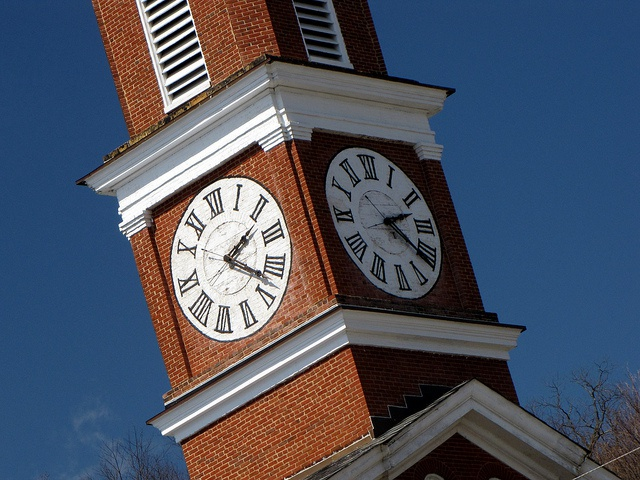Describe the objects in this image and their specific colors. I can see clock in darkblue, white, gray, black, and darkgray tones and clock in darkblue, gray, black, and navy tones in this image. 